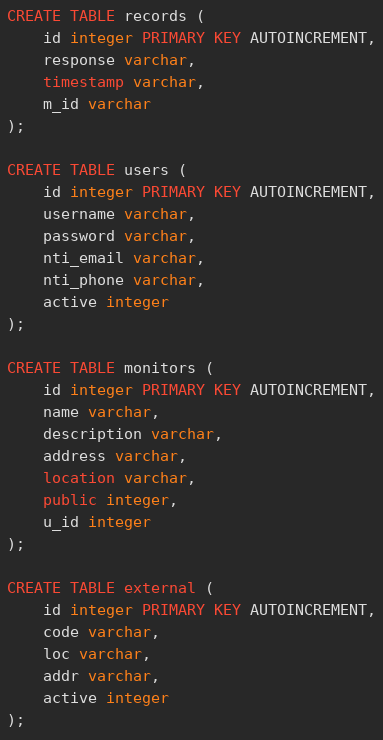<code> <loc_0><loc_0><loc_500><loc_500><_SQL_>CREATE TABLE records (
	id integer PRIMARY KEY AUTOINCREMENT,
	response varchar,
	timestamp varchar,
	m_id varchar
);

CREATE TABLE users (
	id integer PRIMARY KEY AUTOINCREMENT,
	username varchar,
	password varchar,
	nti_email varchar,
	nti_phone varchar,
	active integer
);

CREATE TABLE monitors (
	id integer PRIMARY KEY AUTOINCREMENT,
	name varchar,
	description varchar,
	address varchar,
	location varchar,
	public integer,
	u_id integer
);

CREATE TABLE external (
	id integer PRIMARY KEY AUTOINCREMENT,
	code varchar,
	loc varchar,
	addr varchar,
	active integer
);</code> 